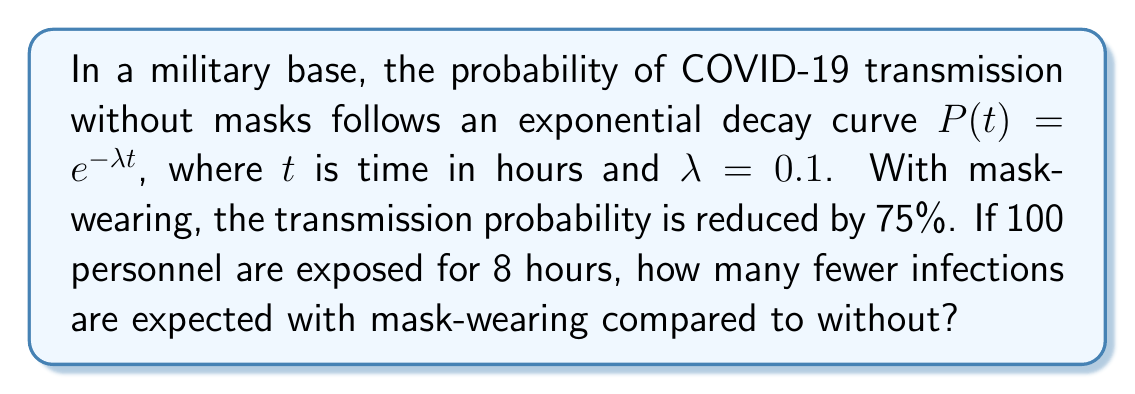Could you help me with this problem? 1) Without masks, the probability of transmission after 8 hours is:
   $P(8) = e^{-0.1 \cdot 8} = e^{-0.8} \approx 0.4493$

2) With masks, the probability is reduced by 75%:
   $P_{mask}(8) = 0.25 \cdot 0.4493 \approx 0.1123$

3) Expected number of infections without masks:
   $100 \cdot 0.4493 \approx 44.93$

4) Expected number of infections with masks:
   $100 \cdot 0.1123 \approx 11.23$

5) Difference in expected infections:
   $44.93 - 11.23 \approx 33.70$

Therefore, approximately 34 fewer infections are expected with mask-wearing.
Answer: 34 